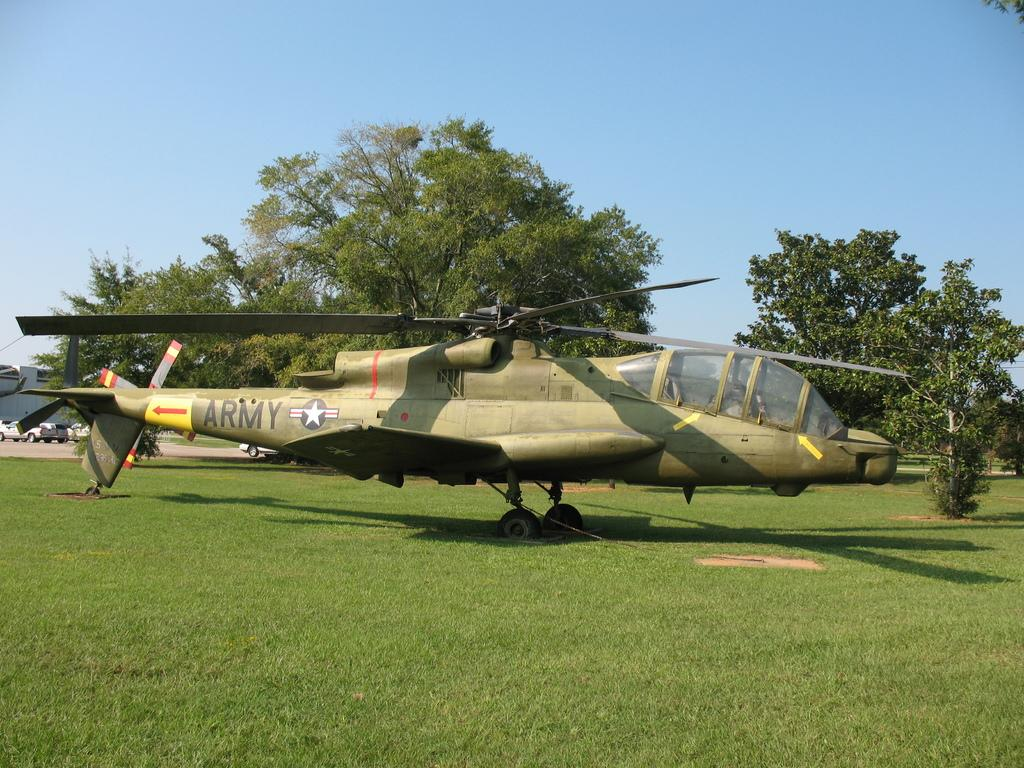<image>
Present a compact description of the photo's key features. A helicopter with the word ARMY printed on the tail. 